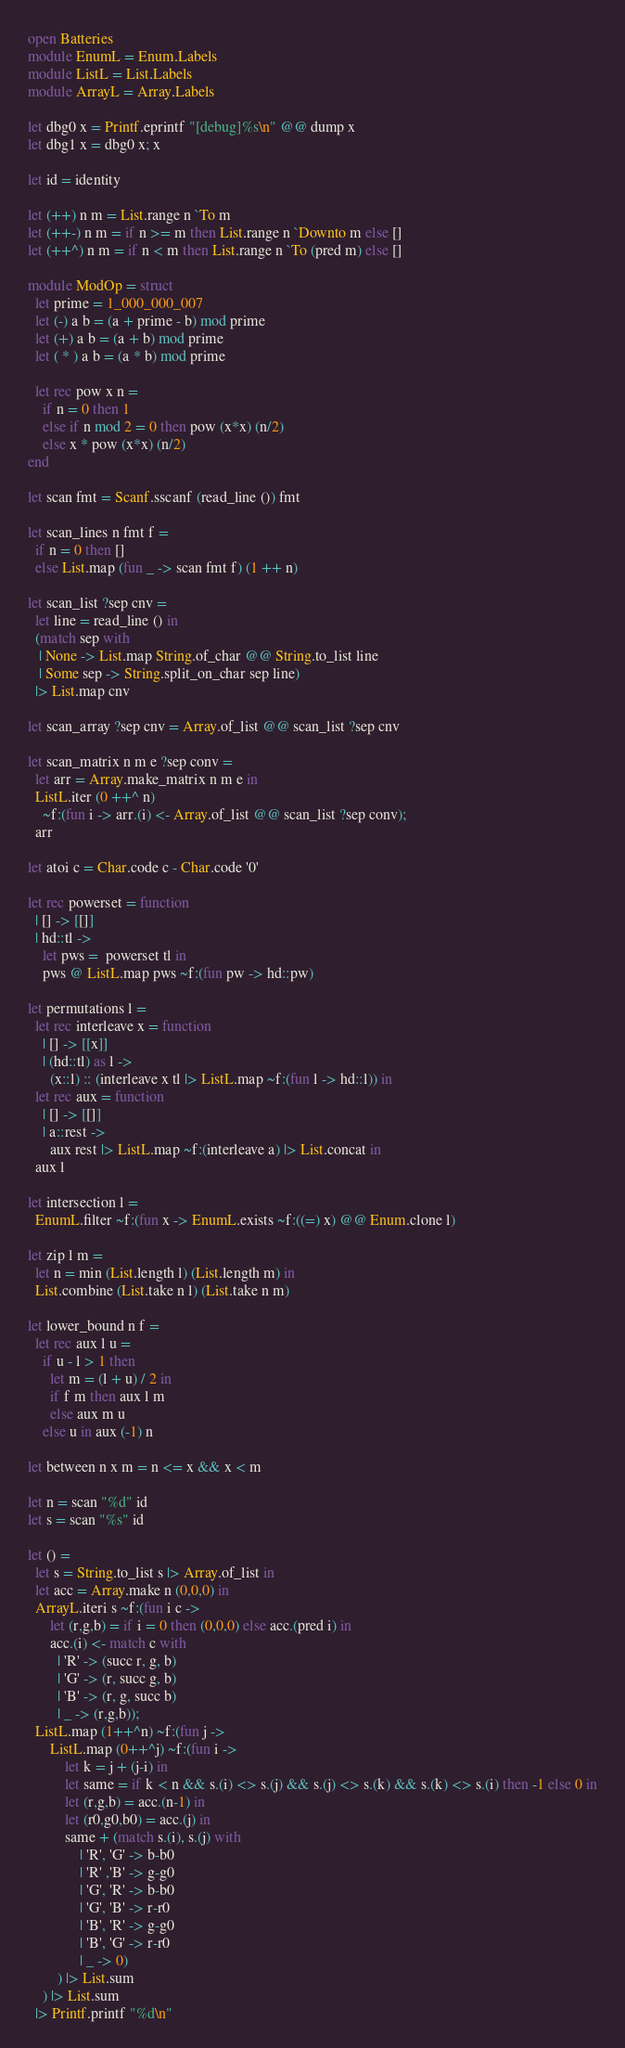Convert code to text. <code><loc_0><loc_0><loc_500><loc_500><_OCaml_>open Batteries
module EnumL = Enum.Labels
module ListL = List.Labels
module ArrayL = Array.Labels

let dbg0 x = Printf.eprintf "[debug]%s\n" @@ dump x
let dbg1 x = dbg0 x; x

let id = identity

let (++) n m = List.range n `To m
let (++-) n m = if n >= m then List.range n `Downto m else []
let (++^) n m = if n < m then List.range n `To (pred m) else []

module ModOp = struct
  let prime = 1_000_000_007
  let (-) a b = (a + prime - b) mod prime
  let (+) a b = (a + b) mod prime
  let ( * ) a b = (a * b) mod prime

  let rec pow x n =
    if n = 0 then 1
    else if n mod 2 = 0 then pow (x*x) (n/2)
    else x * pow (x*x) (n/2)
end

let scan fmt = Scanf.sscanf (read_line ()) fmt

let scan_lines n fmt f =
  if n = 0 then []
  else List.map (fun _ -> scan fmt f) (1 ++ n)

let scan_list ?sep cnv =
  let line = read_line () in
  (match sep with
   | None -> List.map String.of_char @@ String.to_list line
   | Some sep -> String.split_on_char sep line)
  |> List.map cnv

let scan_array ?sep cnv = Array.of_list @@ scan_list ?sep cnv

let scan_matrix n m e ?sep conv =
  let arr = Array.make_matrix n m e in
  ListL.iter (0 ++^ n)
    ~f:(fun i -> arr.(i) <- Array.of_list @@ scan_list ?sep conv);
  arr

let atoi c = Char.code c - Char.code '0'

let rec powerset = function
  | [] -> [[]]
  | hd::tl ->
    let pws =  powerset tl in
    pws @ ListL.map pws ~f:(fun pw -> hd::pw)

let permutations l =
  let rec interleave x = function
    | [] -> [[x]]
    | (hd::tl) as l ->
      (x::l) :: (interleave x tl |> ListL.map ~f:(fun l -> hd::l)) in
  let rec aux = function
    | [] -> [[]]
    | a::rest ->
      aux rest |> ListL.map ~f:(interleave a) |> List.concat in
  aux l

let intersection l =
  EnumL.filter ~f:(fun x -> EnumL.exists ~f:((=) x) @@ Enum.clone l)

let zip l m =
  let n = min (List.length l) (List.length m) in
  List.combine (List.take n l) (List.take n m)

let lower_bound n f =
  let rec aux l u =
    if u - l > 1 then
      let m = (l + u) / 2 in
      if f m then aux l m
      else aux m u
    else u in aux (-1) n

let between n x m = n <= x && x < m

let n = scan "%d" id
let s = scan "%s" id

let () =
  let s = String.to_list s |> Array.of_list in
  let acc = Array.make n (0,0,0) in
  ArrayL.iteri s ~f:(fun i c ->
      let (r,g,b) = if i = 0 then (0,0,0) else acc.(pred i) in
      acc.(i) <- match c with
        | 'R' -> (succ r, g, b)
        | 'G' -> (r, succ g, b)
        | 'B' -> (r, g, succ b)
        | _ -> (r,g,b));
  ListL.map (1++^n) ~f:(fun j ->
      ListL.map (0++^j) ~f:(fun i ->
          let k = j + (j-i) in
          let same = if k < n && s.(i) <> s.(j) && s.(j) <> s.(k) && s.(k) <> s.(i) then -1 else 0 in
          let (r,g,b) = acc.(n-1) in
          let (r0,g0,b0) = acc.(j) in
          same + (match s.(i), s.(j) with
              | 'R', 'G' -> b-b0
              | 'R' ,'B' -> g-g0
              | 'G', 'R' -> b-b0
              | 'G', 'B' -> r-r0
              | 'B', 'R' -> g-g0
              | 'B', 'G' -> r-r0
              | _ -> 0)
        ) |> List.sum
    ) |> List.sum
  |> Printf.printf "%d\n"
</code> 